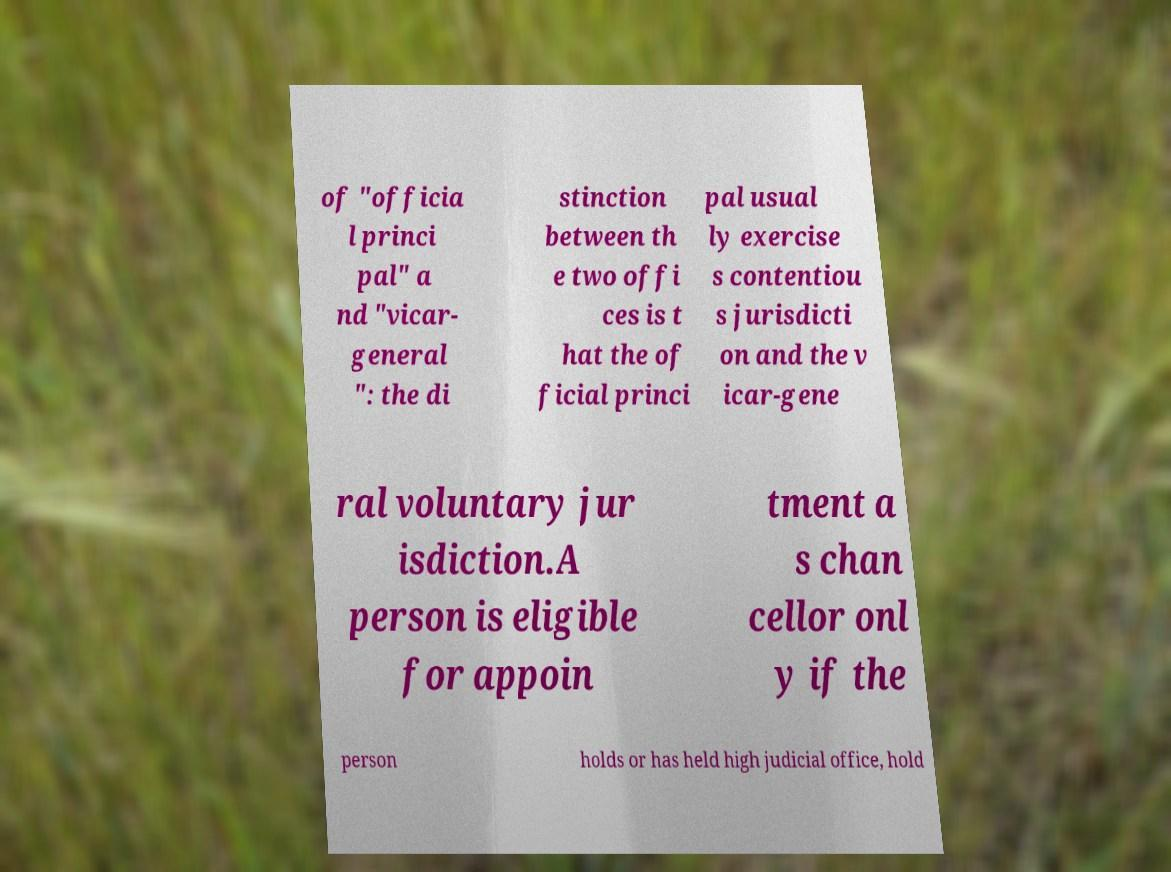I need the written content from this picture converted into text. Can you do that? of "officia l princi pal" a nd "vicar- general ": the di stinction between th e two offi ces is t hat the of ficial princi pal usual ly exercise s contentiou s jurisdicti on and the v icar-gene ral voluntary jur isdiction.A person is eligible for appoin tment a s chan cellor onl y if the person holds or has held high judicial office, hold 